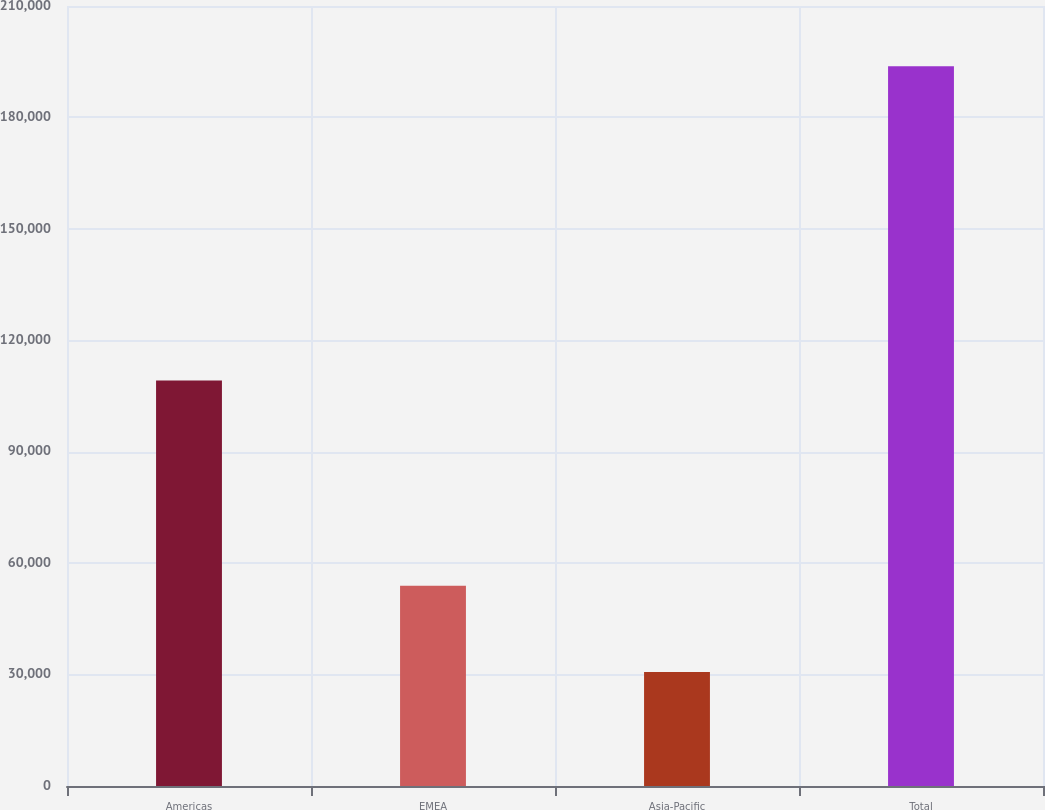Convert chart to OTSL. <chart><loc_0><loc_0><loc_500><loc_500><bar_chart><fcel>Americas<fcel>EMEA<fcel>Asia-Pacific<fcel>Total<nl><fcel>109142<fcel>53935<fcel>30699<fcel>193776<nl></chart> 